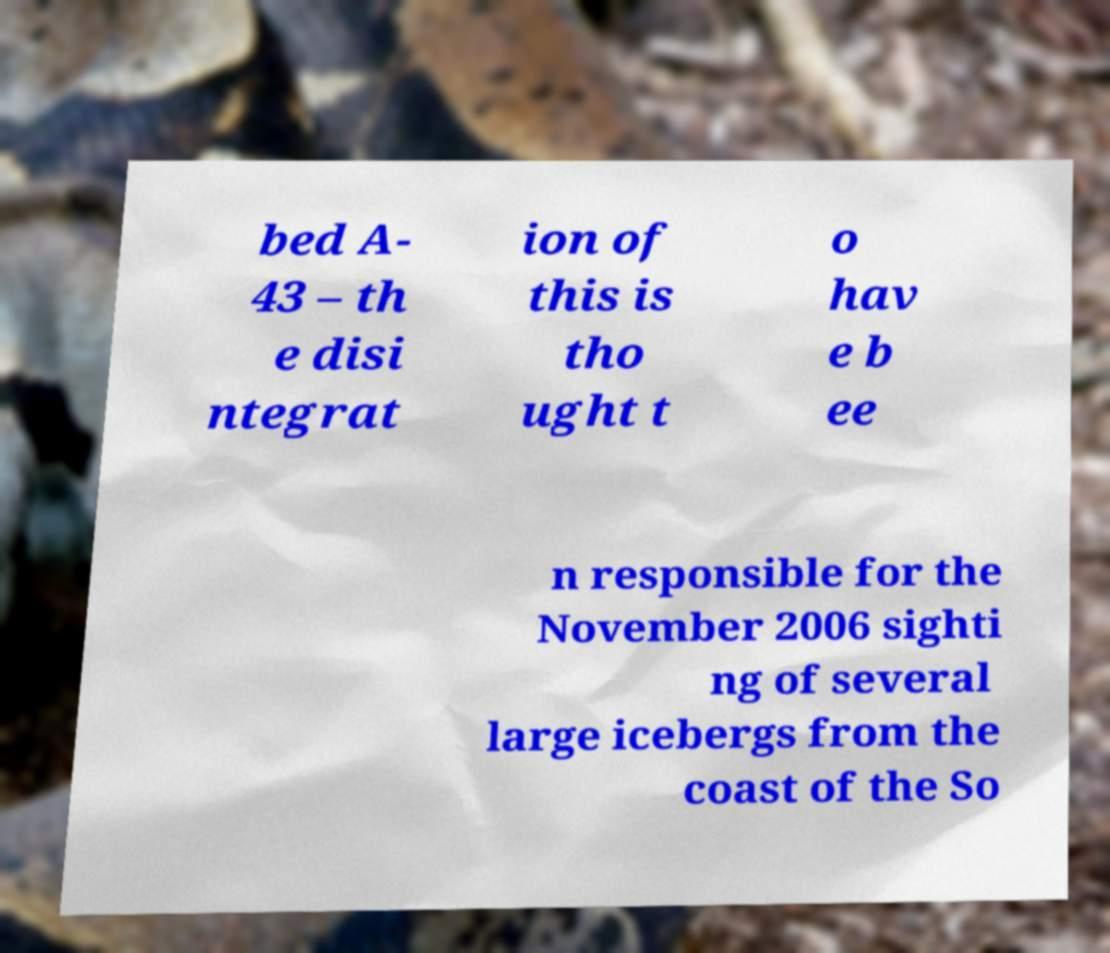There's text embedded in this image that I need extracted. Can you transcribe it verbatim? bed A- 43 – th e disi ntegrat ion of this is tho ught t o hav e b ee n responsible for the November 2006 sighti ng of several large icebergs from the coast of the So 